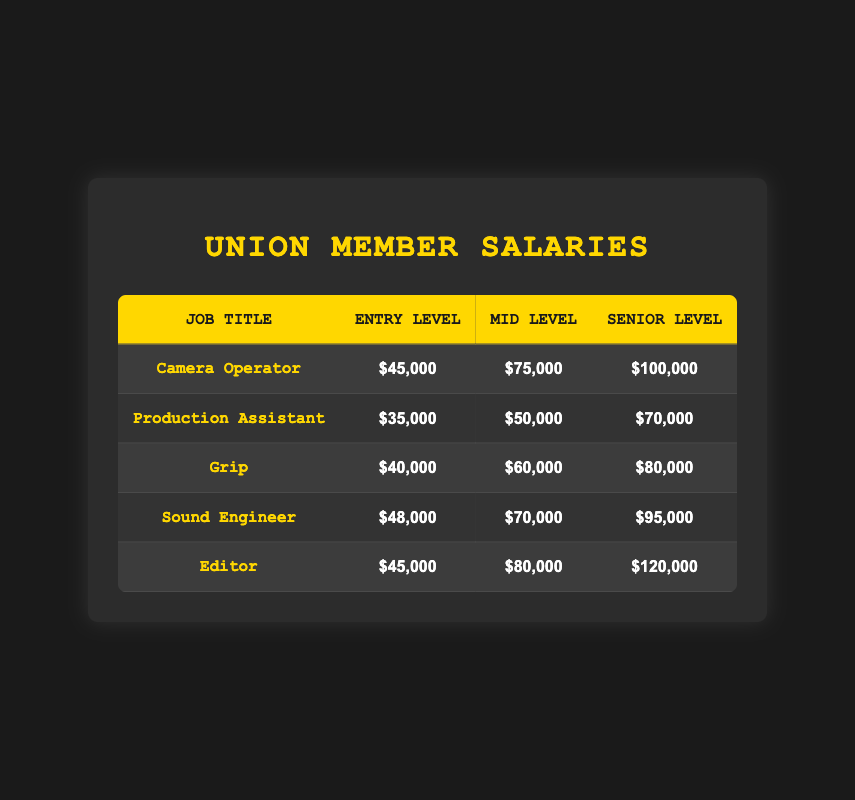What is the average salary for a mid-level Camera Operator? From the table, the average salary for a mid-level Camera Operator is directly stated as $75,000.
Answer: $75,000 What is the average salary of a Grip with senior-level experience? The average salary for a Grip at the senior level according to the table is directly listed as $80,000.
Answer: $80,000 Is the average salary for an Entry Level Sound Engineer higher than that of a Production Assistant? The table shows that the average salary for an Entry Level Sound Engineer is $48,000, while for a Production Assistant it is $35,000. Since $48,000 is greater than $35,000, the statement is true.
Answer: Yes What is the difference between the average salaries of Mid Level Editors and Mid Level Camera Operators? The average salary for a Mid Level Editor is $80,000 and for a Mid Level Camera Operator is $75,000. Thus, the difference is $80,000 - $75,000 = $5,000.
Answer: $5,000 Which job title has the lowest average salary for Entry Level? By examining the table, the job title with the lowest average salary for Entry Level is Production Assistant at $35,000.
Answer: Production Assistant What is the combined average salary for Mid Level Production Assistants and Mid Level Grip? The average salary for Mid Level Production Assistants is $50,000 and for Mid Level Grip is $60,000. The combined average is ($50,000 + $60,000) / 2 = $55,000.
Answer: $55,000 Is it true that all the Senior Level salaries are above $90,000? Checking the Senior Level salaries, Editor has an average of $120,000, Sound Engineer $95,000, but Grip and Production Assistant have $80,000 and $70,000 respectively. Since not all are above $90,000, the statement is false.
Answer: No What is the average salary of all Entry Level positions combined? To find the average salary for all Entry Level positions: (45,000 + 35,000 + 40,000 + 48,000 + 45,000) / 5 = 43,000.
Answer: $43,000 Which job title has the highest average salary for Senior Level? Based on the table, the job title with the highest average salary for Senior Level is Editor at $120,000.
Answer: Editor 